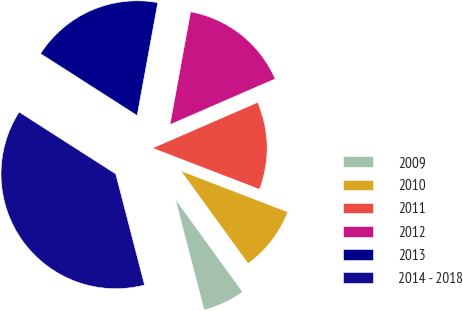Convert chart to OTSL. <chart><loc_0><loc_0><loc_500><loc_500><pie_chart><fcel>2009<fcel>2010<fcel>2011<fcel>2012<fcel>2013<fcel>2014 - 2018<nl><fcel>5.95%<fcel>9.16%<fcel>12.38%<fcel>15.59%<fcel>18.81%<fcel>38.1%<nl></chart> 